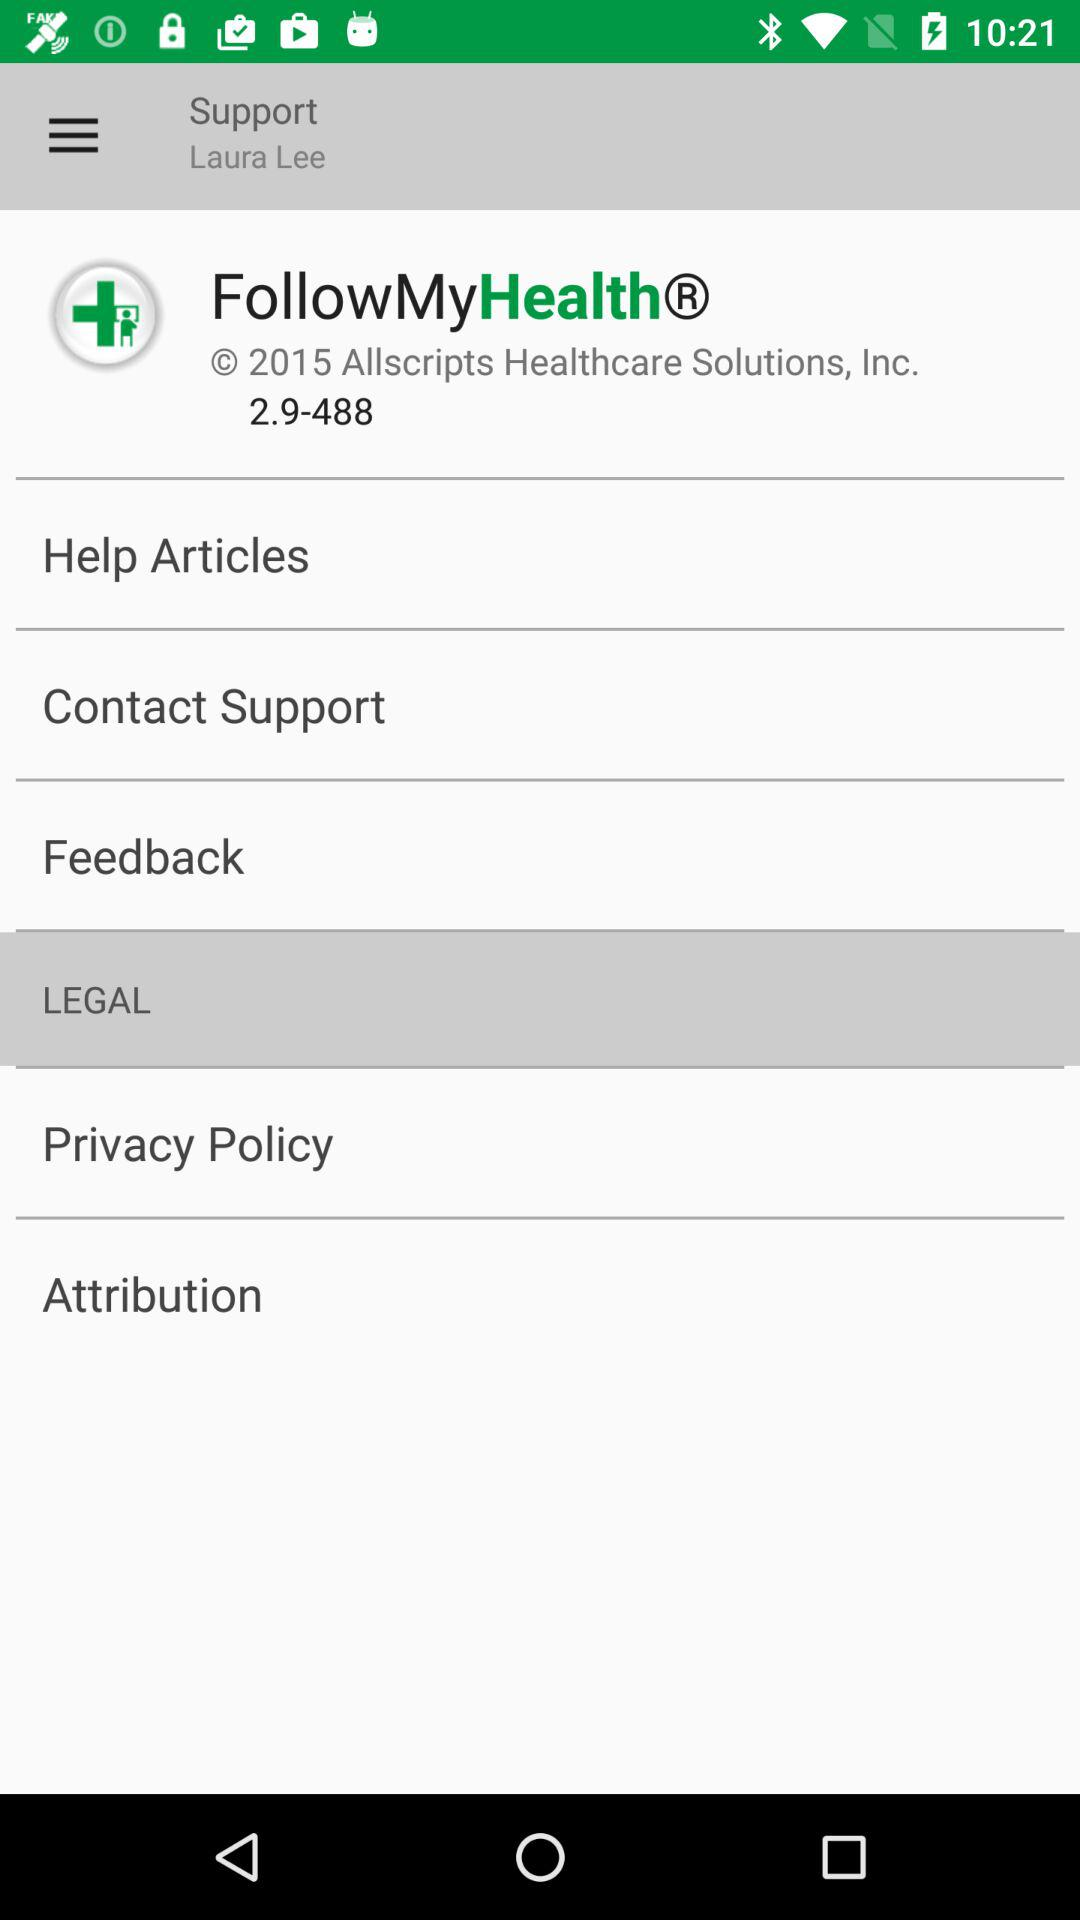What is the name shown on the screen? The name shown on the screen is Laura Lee. 